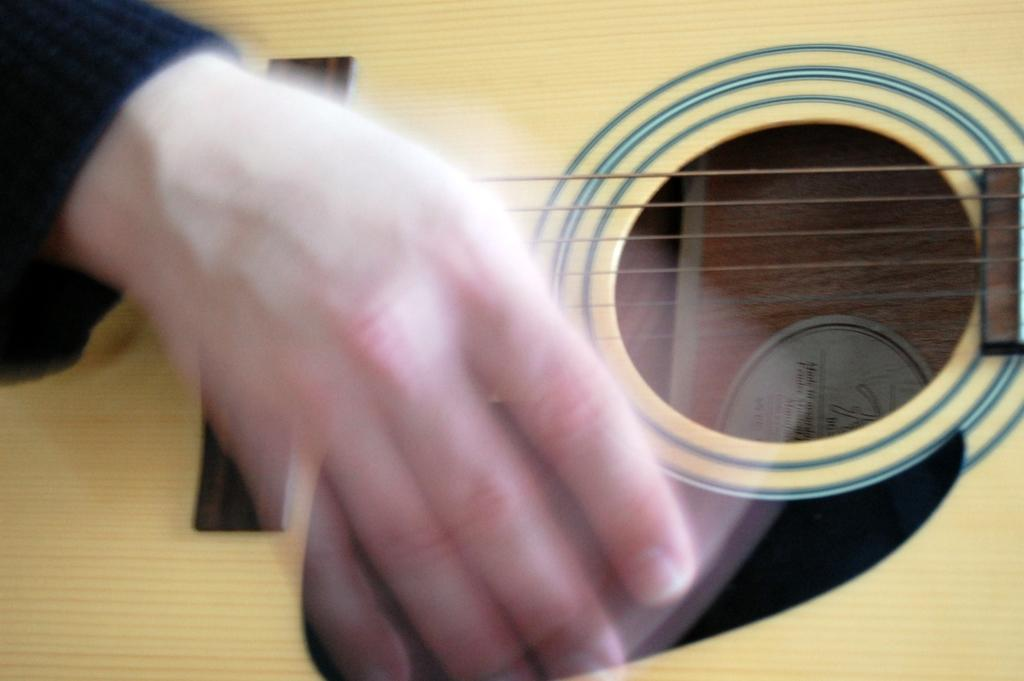What part of a person can be seen in the image? There is a person's hand in the image. What object is the person's hand interacting with in the image? There is a guitar in the image. What type of gold jewelry is the person wearing on their hand in the image? There is no gold jewelry visible on the person's hand in the image. Is the person's brother present in the image? The provided facts do not mention the presence of a brother, so it cannot be determined from the image. 